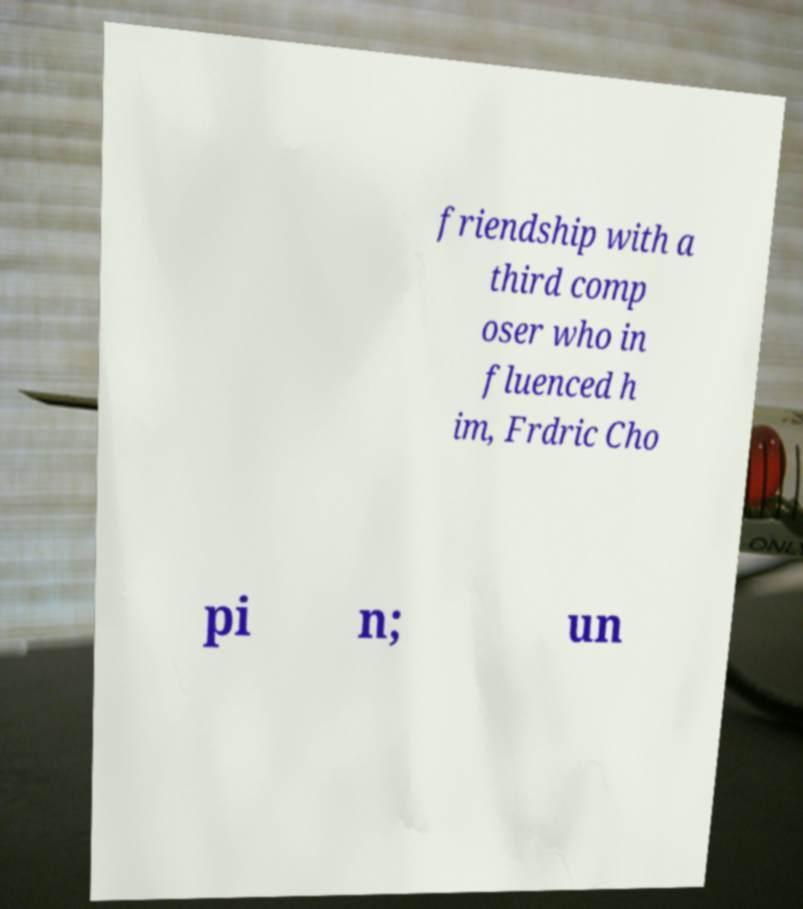Please read and relay the text visible in this image. What does it say? friendship with a third comp oser who in fluenced h im, Frdric Cho pi n; un 